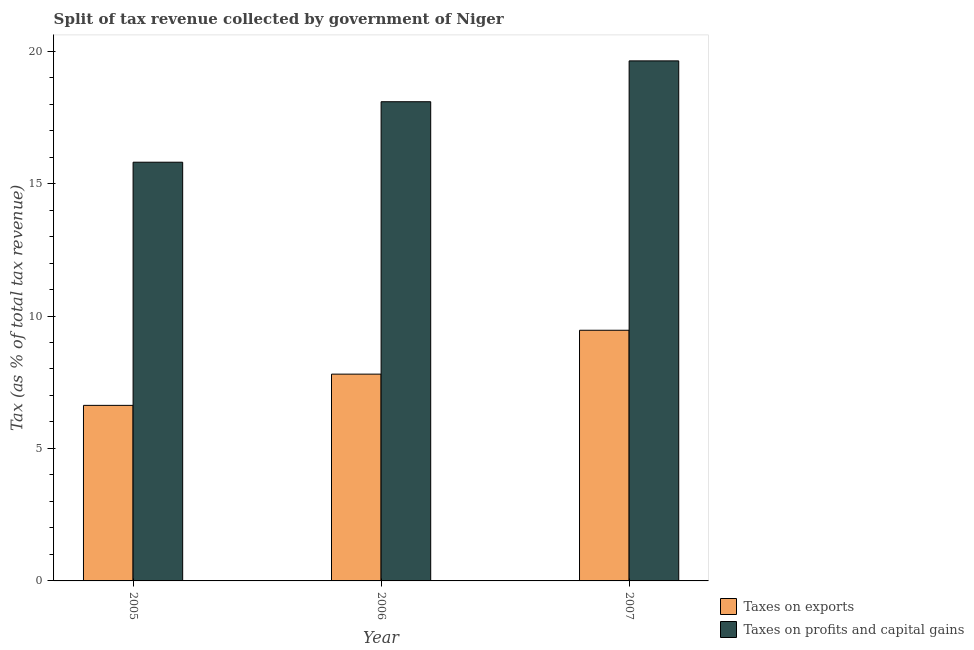How many bars are there on the 2nd tick from the right?
Offer a terse response. 2. In how many cases, is the number of bars for a given year not equal to the number of legend labels?
Keep it short and to the point. 0. What is the percentage of revenue obtained from taxes on profits and capital gains in 2005?
Offer a very short reply. 15.81. Across all years, what is the maximum percentage of revenue obtained from taxes on exports?
Offer a terse response. 9.46. Across all years, what is the minimum percentage of revenue obtained from taxes on exports?
Provide a succinct answer. 6.63. In which year was the percentage of revenue obtained from taxes on profits and capital gains maximum?
Provide a succinct answer. 2007. In which year was the percentage of revenue obtained from taxes on exports minimum?
Ensure brevity in your answer.  2005. What is the total percentage of revenue obtained from taxes on exports in the graph?
Give a very brief answer. 23.89. What is the difference between the percentage of revenue obtained from taxes on exports in 2006 and that in 2007?
Provide a succinct answer. -1.66. What is the difference between the percentage of revenue obtained from taxes on exports in 2006 and the percentage of revenue obtained from taxes on profits and capital gains in 2007?
Your response must be concise. -1.66. What is the average percentage of revenue obtained from taxes on profits and capital gains per year?
Keep it short and to the point. 17.84. In the year 2007, what is the difference between the percentage of revenue obtained from taxes on exports and percentage of revenue obtained from taxes on profits and capital gains?
Offer a terse response. 0. In how many years, is the percentage of revenue obtained from taxes on profits and capital gains greater than 1 %?
Give a very brief answer. 3. What is the ratio of the percentage of revenue obtained from taxes on profits and capital gains in 2005 to that in 2007?
Your answer should be very brief. 0.81. Is the difference between the percentage of revenue obtained from taxes on exports in 2005 and 2006 greater than the difference between the percentage of revenue obtained from taxes on profits and capital gains in 2005 and 2006?
Offer a terse response. No. What is the difference between the highest and the second highest percentage of revenue obtained from taxes on profits and capital gains?
Provide a short and direct response. 1.54. What is the difference between the highest and the lowest percentage of revenue obtained from taxes on exports?
Give a very brief answer. 2.83. Is the sum of the percentage of revenue obtained from taxes on exports in 2006 and 2007 greater than the maximum percentage of revenue obtained from taxes on profits and capital gains across all years?
Ensure brevity in your answer.  Yes. What does the 1st bar from the left in 2007 represents?
Ensure brevity in your answer.  Taxes on exports. What does the 2nd bar from the right in 2007 represents?
Your response must be concise. Taxes on exports. How many years are there in the graph?
Make the answer very short. 3. Are the values on the major ticks of Y-axis written in scientific E-notation?
Offer a very short reply. No. Where does the legend appear in the graph?
Ensure brevity in your answer.  Bottom right. How are the legend labels stacked?
Make the answer very short. Vertical. What is the title of the graph?
Provide a short and direct response. Split of tax revenue collected by government of Niger. What is the label or title of the Y-axis?
Your response must be concise. Tax (as % of total tax revenue). What is the Tax (as % of total tax revenue) in Taxes on exports in 2005?
Offer a very short reply. 6.63. What is the Tax (as % of total tax revenue) of Taxes on profits and capital gains in 2005?
Keep it short and to the point. 15.81. What is the Tax (as % of total tax revenue) of Taxes on exports in 2006?
Offer a very short reply. 7.81. What is the Tax (as % of total tax revenue) in Taxes on profits and capital gains in 2006?
Offer a very short reply. 18.09. What is the Tax (as % of total tax revenue) of Taxes on exports in 2007?
Your answer should be very brief. 9.46. What is the Tax (as % of total tax revenue) of Taxes on profits and capital gains in 2007?
Your answer should be very brief. 19.63. Across all years, what is the maximum Tax (as % of total tax revenue) of Taxes on exports?
Provide a succinct answer. 9.46. Across all years, what is the maximum Tax (as % of total tax revenue) in Taxes on profits and capital gains?
Your answer should be very brief. 19.63. Across all years, what is the minimum Tax (as % of total tax revenue) in Taxes on exports?
Your response must be concise. 6.63. Across all years, what is the minimum Tax (as % of total tax revenue) of Taxes on profits and capital gains?
Keep it short and to the point. 15.81. What is the total Tax (as % of total tax revenue) of Taxes on exports in the graph?
Your answer should be very brief. 23.89. What is the total Tax (as % of total tax revenue) of Taxes on profits and capital gains in the graph?
Provide a succinct answer. 53.53. What is the difference between the Tax (as % of total tax revenue) in Taxes on exports in 2005 and that in 2006?
Your response must be concise. -1.18. What is the difference between the Tax (as % of total tax revenue) in Taxes on profits and capital gains in 2005 and that in 2006?
Give a very brief answer. -2.28. What is the difference between the Tax (as % of total tax revenue) in Taxes on exports in 2005 and that in 2007?
Your answer should be compact. -2.83. What is the difference between the Tax (as % of total tax revenue) of Taxes on profits and capital gains in 2005 and that in 2007?
Offer a very short reply. -3.83. What is the difference between the Tax (as % of total tax revenue) of Taxes on exports in 2006 and that in 2007?
Offer a very short reply. -1.66. What is the difference between the Tax (as % of total tax revenue) of Taxes on profits and capital gains in 2006 and that in 2007?
Offer a terse response. -1.54. What is the difference between the Tax (as % of total tax revenue) of Taxes on exports in 2005 and the Tax (as % of total tax revenue) of Taxes on profits and capital gains in 2006?
Offer a very short reply. -11.46. What is the difference between the Tax (as % of total tax revenue) of Taxes on exports in 2005 and the Tax (as % of total tax revenue) of Taxes on profits and capital gains in 2007?
Provide a succinct answer. -13. What is the difference between the Tax (as % of total tax revenue) in Taxes on exports in 2006 and the Tax (as % of total tax revenue) in Taxes on profits and capital gains in 2007?
Make the answer very short. -11.82. What is the average Tax (as % of total tax revenue) in Taxes on exports per year?
Make the answer very short. 7.96. What is the average Tax (as % of total tax revenue) in Taxes on profits and capital gains per year?
Your answer should be compact. 17.84. In the year 2005, what is the difference between the Tax (as % of total tax revenue) of Taxes on exports and Tax (as % of total tax revenue) of Taxes on profits and capital gains?
Your answer should be very brief. -9.18. In the year 2006, what is the difference between the Tax (as % of total tax revenue) of Taxes on exports and Tax (as % of total tax revenue) of Taxes on profits and capital gains?
Ensure brevity in your answer.  -10.28. In the year 2007, what is the difference between the Tax (as % of total tax revenue) of Taxes on exports and Tax (as % of total tax revenue) of Taxes on profits and capital gains?
Your answer should be compact. -10.17. What is the ratio of the Tax (as % of total tax revenue) of Taxes on exports in 2005 to that in 2006?
Your answer should be very brief. 0.85. What is the ratio of the Tax (as % of total tax revenue) in Taxes on profits and capital gains in 2005 to that in 2006?
Your response must be concise. 0.87. What is the ratio of the Tax (as % of total tax revenue) in Taxes on exports in 2005 to that in 2007?
Ensure brevity in your answer.  0.7. What is the ratio of the Tax (as % of total tax revenue) of Taxes on profits and capital gains in 2005 to that in 2007?
Your response must be concise. 0.81. What is the ratio of the Tax (as % of total tax revenue) of Taxes on exports in 2006 to that in 2007?
Ensure brevity in your answer.  0.82. What is the ratio of the Tax (as % of total tax revenue) of Taxes on profits and capital gains in 2006 to that in 2007?
Your answer should be compact. 0.92. What is the difference between the highest and the second highest Tax (as % of total tax revenue) in Taxes on exports?
Your answer should be very brief. 1.66. What is the difference between the highest and the second highest Tax (as % of total tax revenue) of Taxes on profits and capital gains?
Offer a terse response. 1.54. What is the difference between the highest and the lowest Tax (as % of total tax revenue) in Taxes on exports?
Your answer should be compact. 2.83. What is the difference between the highest and the lowest Tax (as % of total tax revenue) of Taxes on profits and capital gains?
Provide a short and direct response. 3.83. 